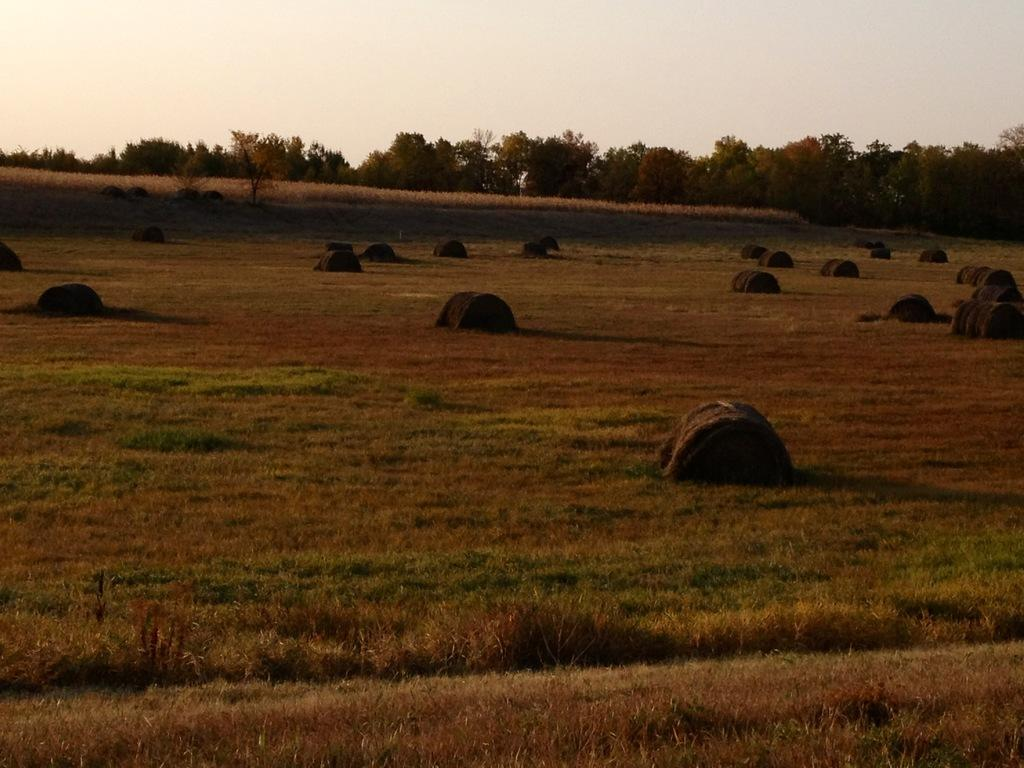What is the main subject in the center of the image? There are many tents in the center of the image. What can be seen in the background of the image? There are trees in the background of the image. What type of ground is visible at the bottom of the image? There is grass at the bottom of the image. How many legs can be seen on the mother in the image? There is no mother or legs present in the image. What type of bomb is visible in the image? There is no bomb present in the image. 